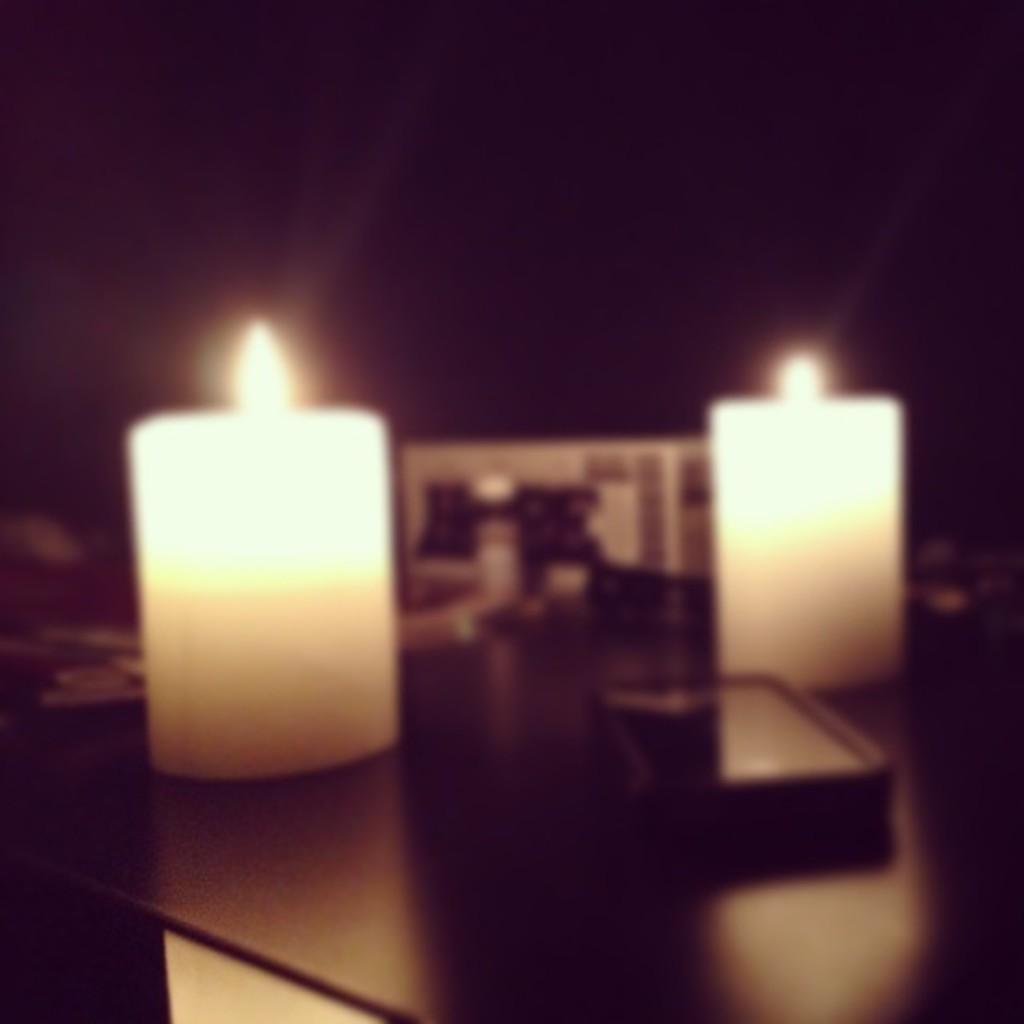How would you summarize this image in a sentence or two? In this picture we can see 2 candles and other things kept on a black table. The background is dark. 